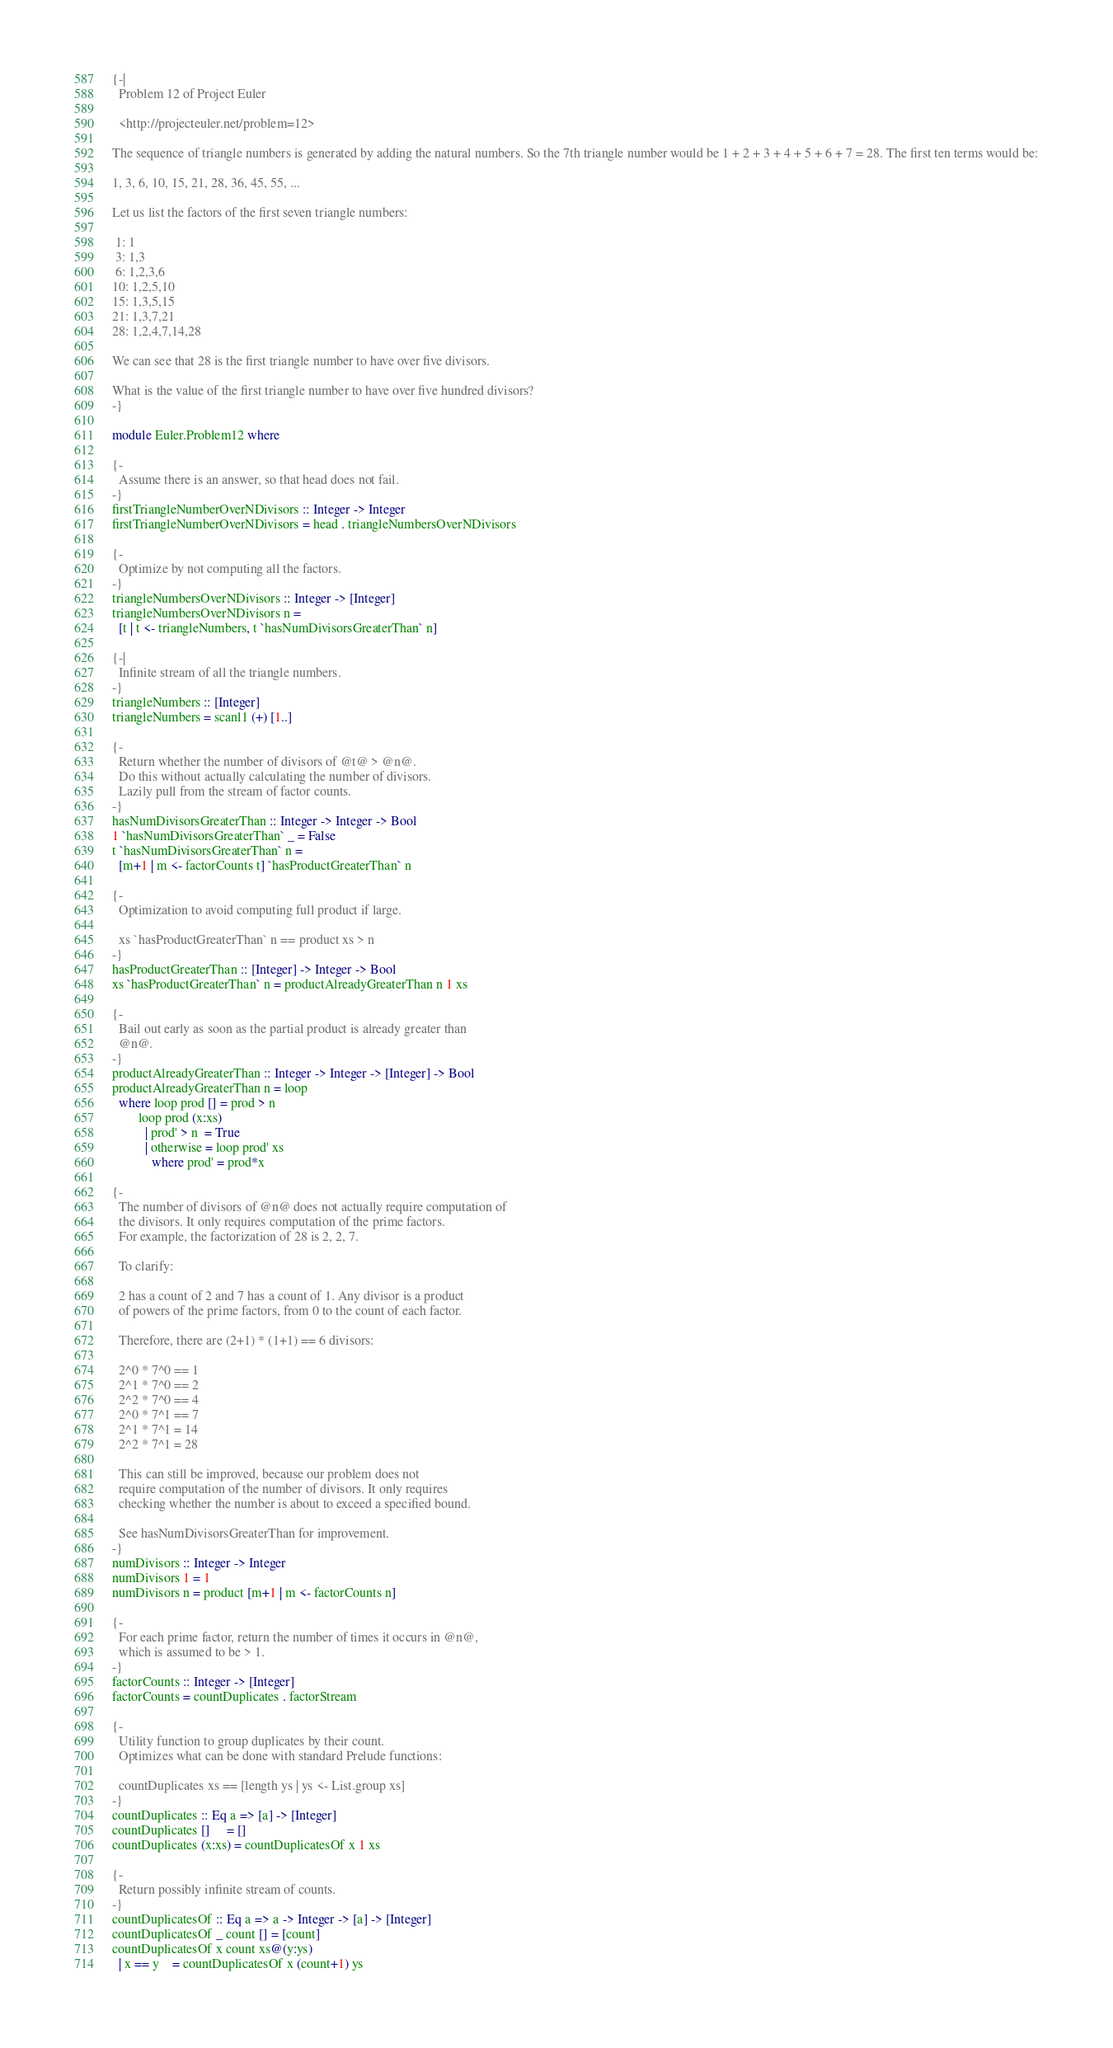<code> <loc_0><loc_0><loc_500><loc_500><_Haskell_>{-|
  Problem 12 of Project Euler

  <http://projecteuler.net/problem=12>

The sequence of triangle numbers is generated by adding the natural numbers. So the 7th triangle number would be 1 + 2 + 3 + 4 + 5 + 6 + 7 = 28. The first ten terms would be:

1, 3, 6, 10, 15, 21, 28, 36, 45, 55, ...

Let us list the factors of the first seven triangle numbers:

 1: 1
 3: 1,3
 6: 1,2,3,6
10: 1,2,5,10
15: 1,3,5,15
21: 1,3,7,21
28: 1,2,4,7,14,28

We can see that 28 is the first triangle number to have over five divisors.

What is the value of the first triangle number to have over five hundred divisors?
-}

module Euler.Problem12 where

{-
  Assume there is an answer, so that head does not fail.
-}
firstTriangleNumberOverNDivisors :: Integer -> Integer
firstTriangleNumberOverNDivisors = head . triangleNumbersOverNDivisors

{-
  Optimize by not computing all the factors.
-}
triangleNumbersOverNDivisors :: Integer -> [Integer]
triangleNumbersOverNDivisors n =
  [t | t <- triangleNumbers, t `hasNumDivisorsGreaterThan` n]

{-|
  Infinite stream of all the triangle numbers.
-}
triangleNumbers :: [Integer]
triangleNumbers = scanl1 (+) [1..]

{-
  Return whether the number of divisors of @t@ > @n@.
  Do this without actually calculating the number of divisors.
  Lazily pull from the stream of factor counts.
-}
hasNumDivisorsGreaterThan :: Integer -> Integer -> Bool
1 `hasNumDivisorsGreaterThan` _ = False
t `hasNumDivisorsGreaterThan` n =
  [m+1 | m <- factorCounts t] `hasProductGreaterThan` n

{-
  Optimization to avoid computing full product if large.

  xs `hasProductGreaterThan` n == product xs > n
-}
hasProductGreaterThan :: [Integer] -> Integer -> Bool
xs `hasProductGreaterThan` n = productAlreadyGreaterThan n 1 xs

{-
  Bail out early as soon as the partial product is already greater than
  @n@.
-}
productAlreadyGreaterThan :: Integer -> Integer -> [Integer] -> Bool
productAlreadyGreaterThan n = loop
  where loop prod [] = prod > n
        loop prod (x:xs)
          | prod' > n  = True
          | otherwise = loop prod' xs
            where prod' = prod*x

{-
  The number of divisors of @n@ does not actually require computation of
  the divisors. It only requires computation of the prime factors.
  For example, the factorization of 28 is 2, 2, 7.

  To clarify:

  2 has a count of 2 and 7 has a count of 1. Any divisor is a product
  of powers of the prime factors, from 0 to the count of each factor.

  Therefore, there are (2+1) * (1+1) == 6 divisors:

  2^0 * 7^0 == 1
  2^1 * 7^0 == 2
  2^2 * 7^0 == 4
  2^0 * 7^1 == 7
  2^1 * 7^1 = 14
  2^2 * 7^1 = 28

  This can still be improved, because our problem does not
  require computation of the number of divisors. It only requires
  checking whether the number is about to exceed a specified bound.

  See hasNumDivisorsGreaterThan for improvement.
-}
numDivisors :: Integer -> Integer
numDivisors 1 = 1
numDivisors n = product [m+1 | m <- factorCounts n]

{-
  For each prime factor, return the number of times it occurs in @n@,
  which is assumed to be > 1.
-}
factorCounts :: Integer -> [Integer]
factorCounts = countDuplicates . factorStream

{-
  Utility function to group duplicates by their count.
  Optimizes what can be done with standard Prelude functions:

  countDuplicates xs == [length ys | ys <- List.group xs]
-}
countDuplicates :: Eq a => [a] -> [Integer]
countDuplicates []     = []
countDuplicates (x:xs) = countDuplicatesOf x 1 xs

{-
  Return possibly infinite stream of counts.
-}
countDuplicatesOf :: Eq a => a -> Integer -> [a] -> [Integer]
countDuplicatesOf _ count [] = [count]
countDuplicatesOf x count xs@(y:ys)
  | x == y    = countDuplicatesOf x (count+1) ys</code> 